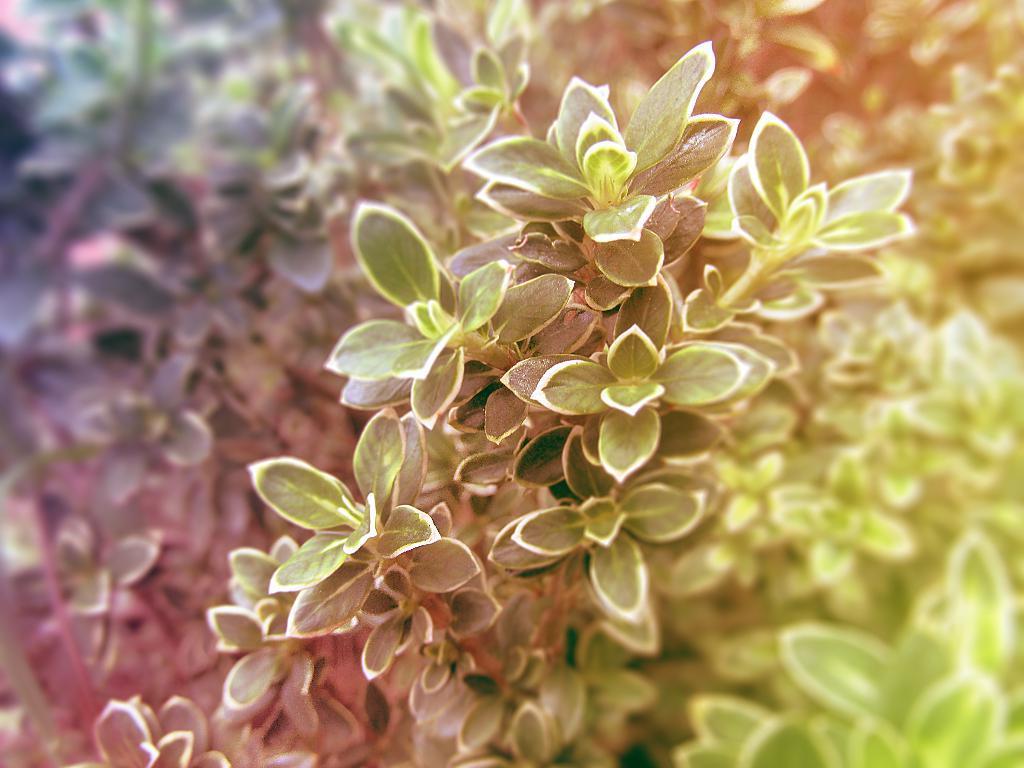Can you describe this image briefly? This is an edited image. I can see the plants with leaves. The background is blurry. 